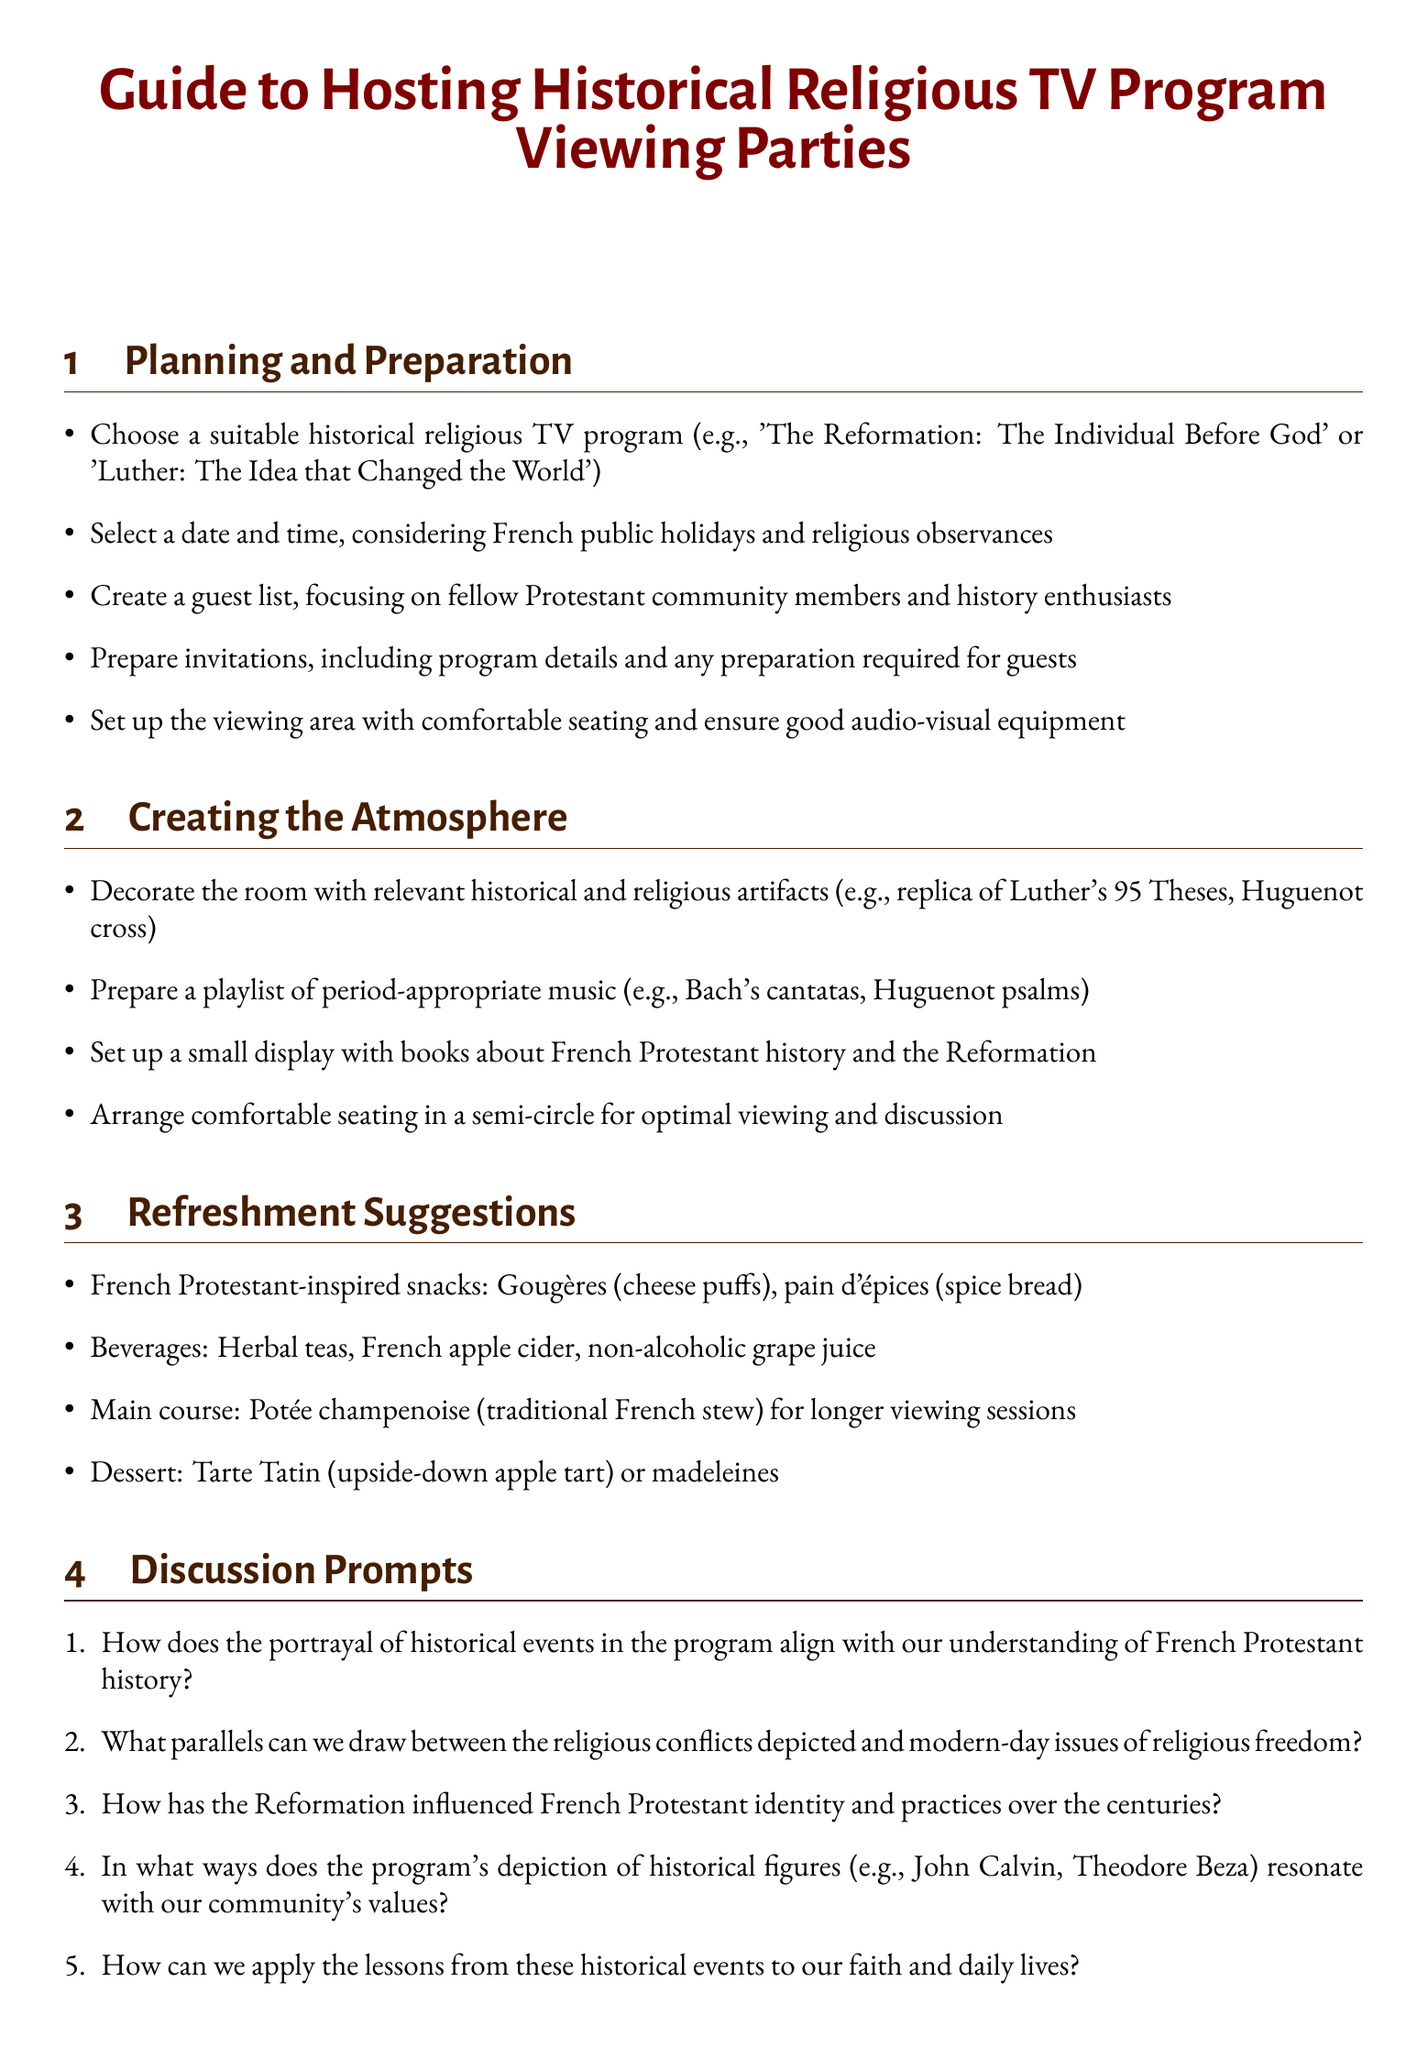What are some recommended snacks? The document lists specific snacks that align with the theme of the viewing party.
Answer: Gougères, pain d'épices Which historical religious TV program is mentioned as an example? The document provides examples of suitable programs for this viewing party.
Answer: The Reformation: The Individual Before God What is one post-viewing activity suggested in the document? The document outlines activities to engage guests after the viewing.
Answer: Group prayer reflecting on the themes of the program How should the seating be arranged according to the guide? The document specifies the arrangement to optimize viewing and discussion.
Answer: Semi-circle What type of beverages are suggested? The document includes a list of appropriate drinks for the event.
Answer: Herbal teas, French apple cider, non-alcoholic grape juice What consideration is advised regarding audio-visual equipment? The document stresses the importance of preparing for any technical issues.
Answer: Test audio-visual equipment before the event What is the theme of the viewing party? The document explicitly focuses on a specific type of program for the event.
Answer: Historical religious TV programs Which aspect of history does the discussion prompt encourage guests to explore? The prompts lead guests into discussions about a specific historical context.
Answer: French Protestant history 